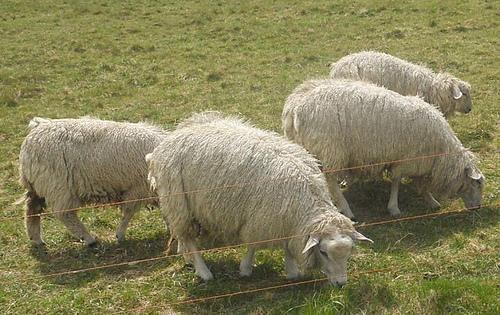How many animals in the picture?
Give a very brief answer. 4. 